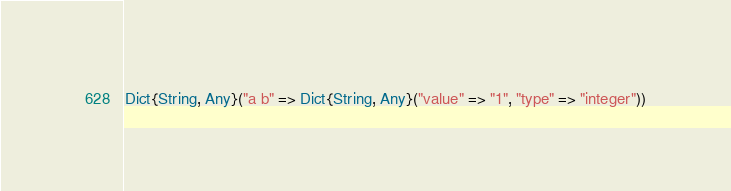Convert code to text. <code><loc_0><loc_0><loc_500><loc_500><_Julia_>Dict{String, Any}("a b" => Dict{String, Any}("value" => "1", "type" => "integer"))</code> 